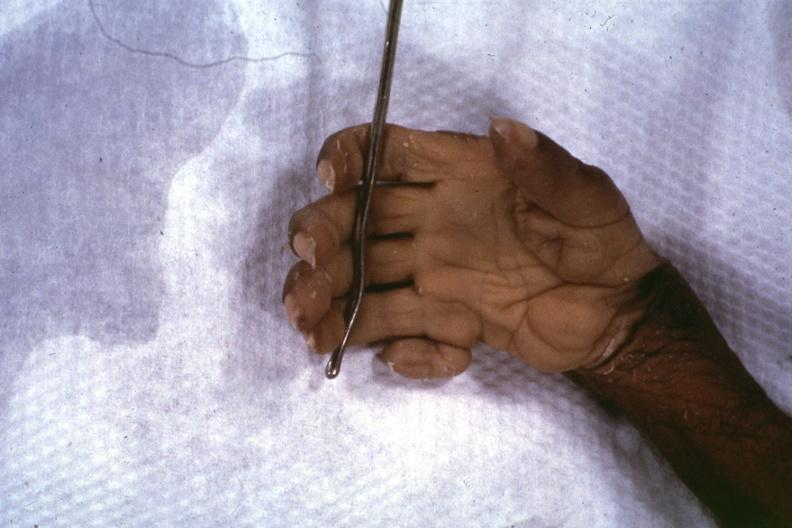s hand present?
Answer the question using a single word or phrase. Hand 